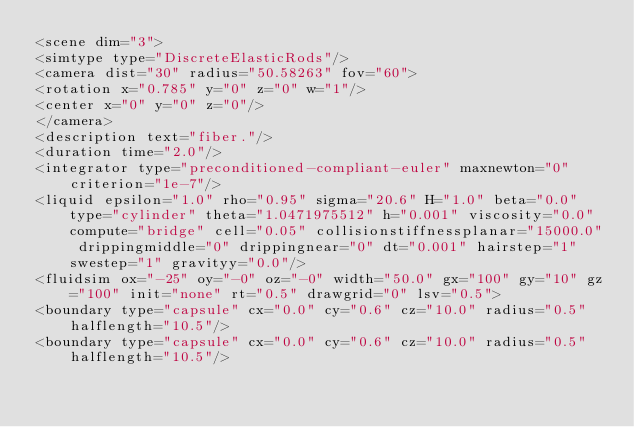<code> <loc_0><loc_0><loc_500><loc_500><_XML_><scene dim="3">
<simtype type="DiscreteElasticRods"/>
<camera dist="30" radius="50.58263" fov="60">
<rotation x="0.785" y="0" z="0" w="1"/>
<center x="0" y="0" z="0"/>
</camera>
<description text="fiber."/>
<duration time="2.0"/>
<integrator type="preconditioned-compliant-euler" maxnewton="0" criterion="1e-7"/>
<liquid epsilon="1.0" rho="0.95" sigma="20.6" H="1.0" beta="0.0" type="cylinder" theta="1.0471975512" h="0.001" viscosity="0.0" compute="bridge" cell="0.05" collisionstiffnessplanar="15000.0" drippingmiddle="0" drippingnear="0" dt="0.001" hairstep="1" swestep="1" gravityy="0.0"/>
<fluidsim ox="-25" oy="-0" oz="-0" width="50.0" gx="100" gy="10" gz="100" init="none" rt="0.5" drawgrid="0" lsv="0.5">
<boundary type="capsule" cx="0.0" cy="0.6" cz="10.0" radius="0.5" halflength="10.5"/>
<boundary type="capsule" cx="0.0" cy="0.6" cz="10.0" radius="0.5" halflength="10.5"/></code> 